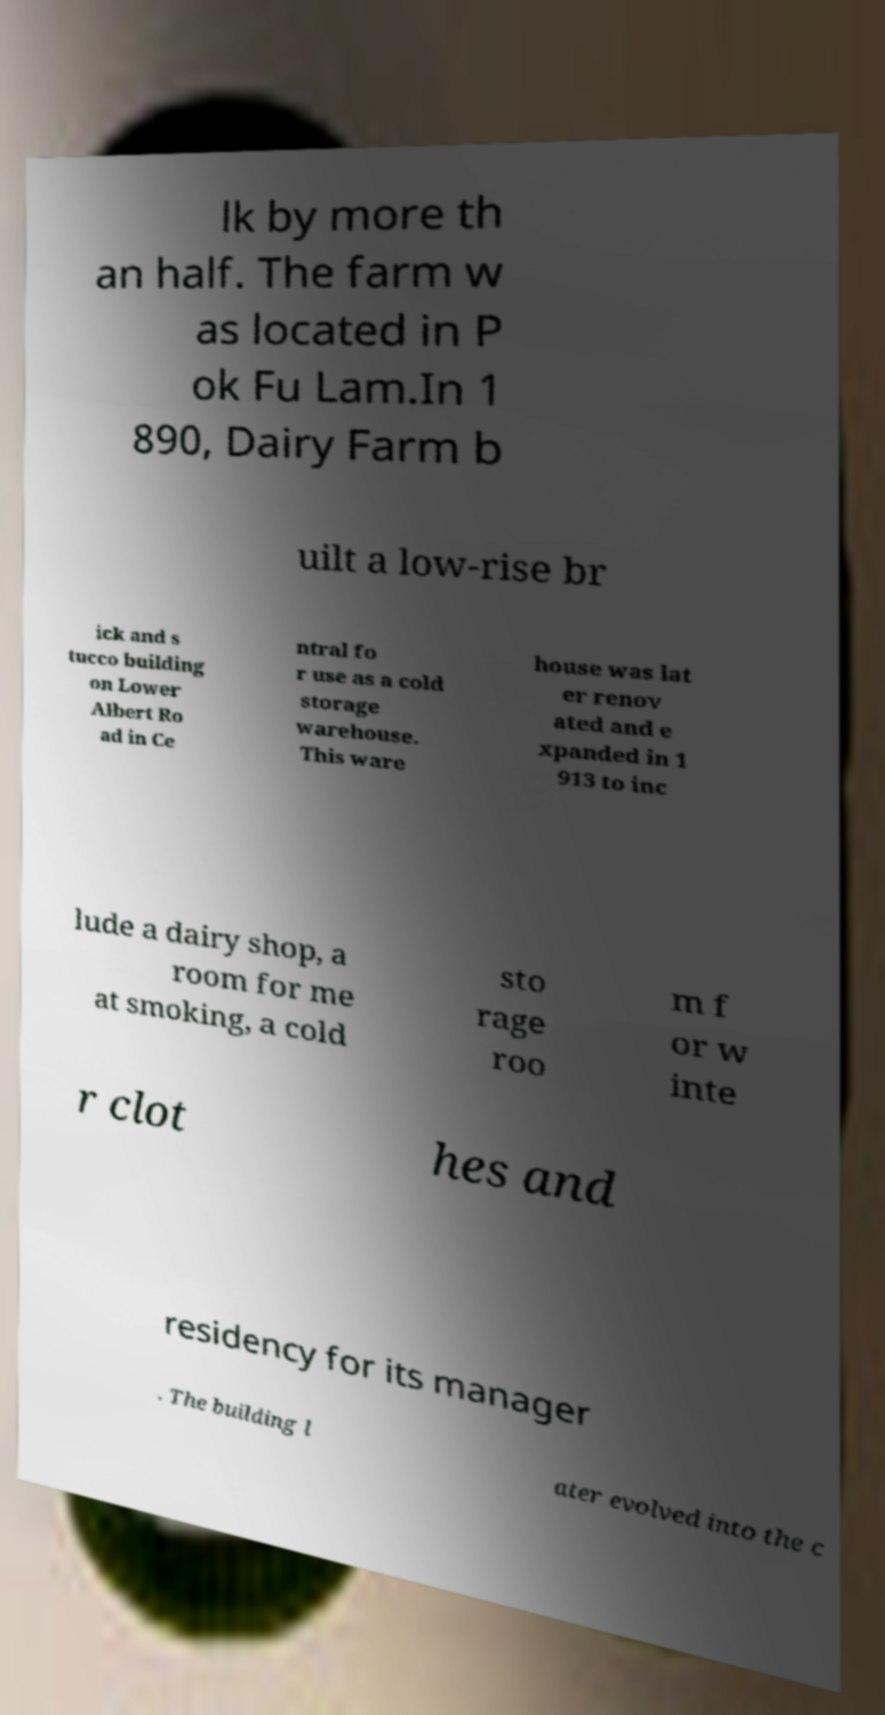For documentation purposes, I need the text within this image transcribed. Could you provide that? lk by more th an half. The farm w as located in P ok Fu Lam.In 1 890, Dairy Farm b uilt a low-rise br ick and s tucco building on Lower Albert Ro ad in Ce ntral fo r use as a cold storage warehouse. This ware house was lat er renov ated and e xpanded in 1 913 to inc lude a dairy shop, a room for me at smoking, a cold sto rage roo m f or w inte r clot hes and residency for its manager . The building l ater evolved into the c 